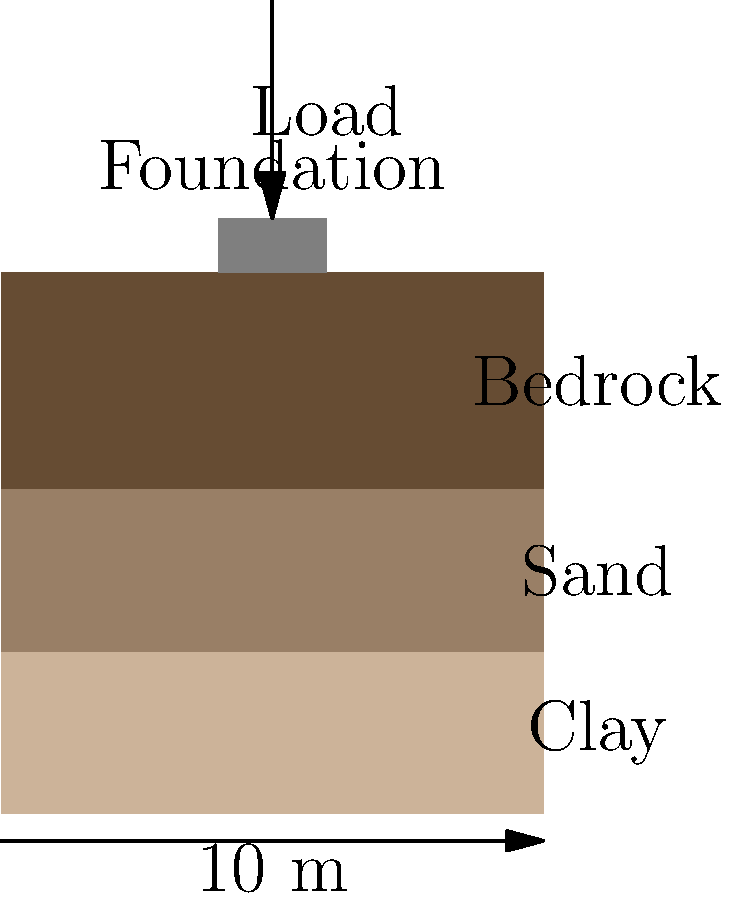As a music historian with a passion for classic pop bands, you've been tasked with estimating the settlement of a new museum foundation dedicated to the Osmonds. The soil profile consists of a 3m thick clay layer (compression index $C_c = 0.2$, initial void ratio $e_0 = 0.9$) over bedrock. If the foundation exerts a pressure of 200 kPa and the initial effective stress at the middle of the clay layer is 30 kPa, what is the estimated settlement in centimeters? Assume the clay layer is normally consolidated. Let's approach this step-by-step, relating it to our Osmonds museum project:

1) For normally consolidated clay, we use the compression index method:

   $S = \frac{H}{1+e_0} C_c \log_{10}(\frac{\sigma'_0 + \Delta\sigma}{\sigma'_0})$

   Where:
   $S$ = Settlement
   $H$ = Thickness of clay layer
   $e_0$ = Initial void ratio
   $C_c$ = Compression index
   $\sigma'_0$ = Initial effective stress
   $\Delta\sigma$ = Change in stress (applied foundation pressure)

2) We have:
   $H = 3$ m
   $e_0 = 0.9$
   $C_c = 0.2$
   $\sigma'_0 = 30$ kPa
   $\Delta\sigma = 200$ kPa

3) Plugging these values into our equation:

   $S = \frac{3}{1+0.9} \cdot 0.2 \cdot \log_{10}(\frac{30 + 200}{30})$

4) Simplify:
   $S = 1.579 \cdot 0.2 \cdot \log_{10}(7.667)$

5) Calculate:
   $S = 0.316 \cdot 0.884 = 0.279$ m

6) Convert to centimeters:
   $S = 0.279 \cdot 100 = 27.9$ cm

So, just as the Osmonds' career had its ups and downs, our museum foundation will settle about 27.9 cm.
Answer: 27.9 cm 